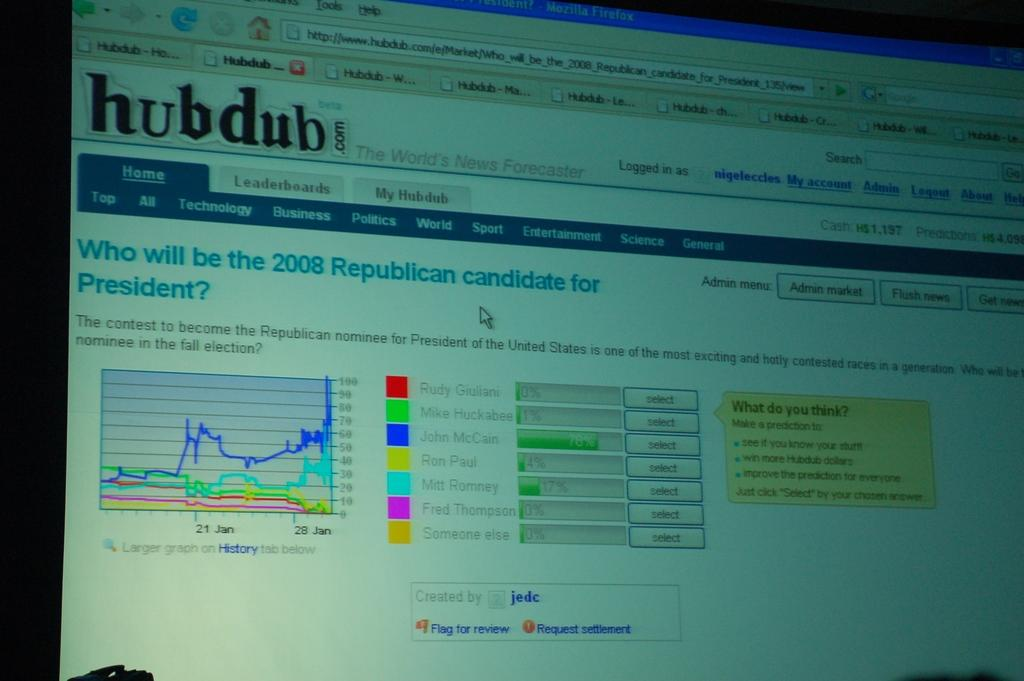<image>
Offer a succinct explanation of the picture presented. a computer screen is open to hubdub websites 